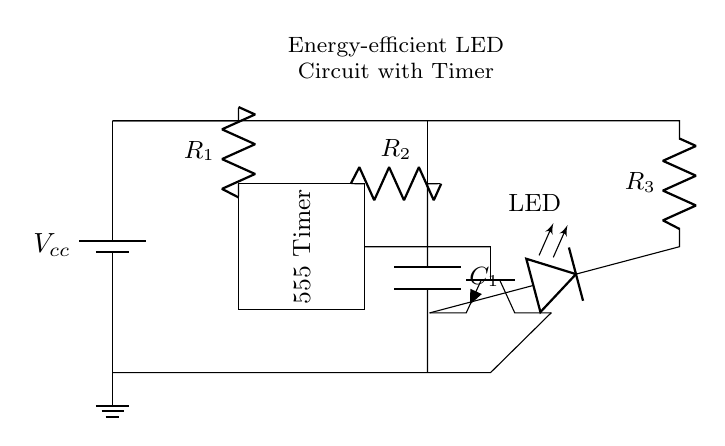What is the power supply type in this circuit? The circuit uses a battery as power supply, indicated by the battery symbol at the start of the circuit.
Answer: Battery What component is used to control the timing in this circuit? The timer IC labeled as 555 is used to control the timing for the LED operation, as shown in the rectangle with the label.
Answer: 555 Timer What is the function of the transistor in this circuit? The transistor acts as a switch that controls the LED's power. It receives a signal from the timer and either allows or cuts off current to the LED.
Answer: Switch How many resistors are present in the circuit? There are three resistors labeled as R1, R2, and R3, which are visible in the connections to the timer and the LED.
Answer: Three What does the capacitor in this circuit do? The capacitor connected to the timer helps determine the time duration for which the LED remains on by charging and discharging as per the timer operation.
Answer: Timing What is the purpose of the LED in the circuit? The LED serves as the output that illuminates when powered, providing visible indication of operation based on the timing circuit.
Answer: Illumination How is the LED connected to the transistor? The LED is connected through the collector of the transistor so that when the transistor is on, it can allow current to flow through the LED, illuminating it.
Answer: Collector connection 